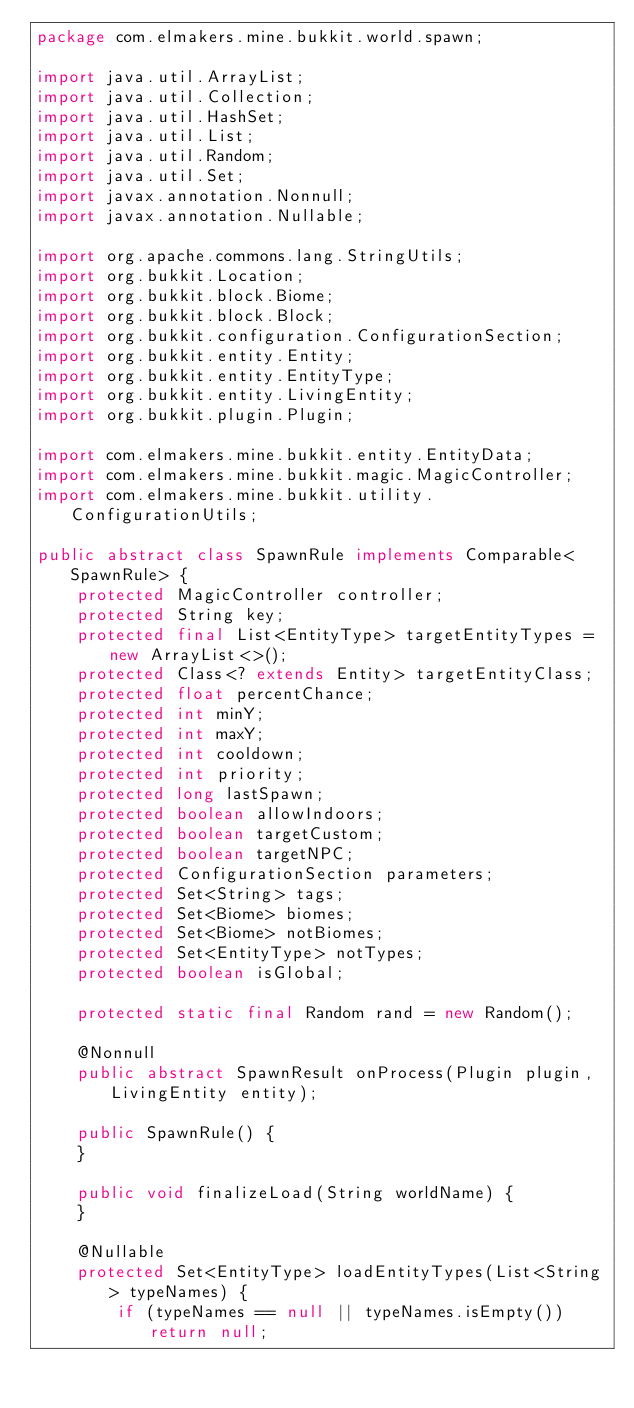<code> <loc_0><loc_0><loc_500><loc_500><_Java_>package com.elmakers.mine.bukkit.world.spawn;

import java.util.ArrayList;
import java.util.Collection;
import java.util.HashSet;
import java.util.List;
import java.util.Random;
import java.util.Set;
import javax.annotation.Nonnull;
import javax.annotation.Nullable;

import org.apache.commons.lang.StringUtils;
import org.bukkit.Location;
import org.bukkit.block.Biome;
import org.bukkit.block.Block;
import org.bukkit.configuration.ConfigurationSection;
import org.bukkit.entity.Entity;
import org.bukkit.entity.EntityType;
import org.bukkit.entity.LivingEntity;
import org.bukkit.plugin.Plugin;

import com.elmakers.mine.bukkit.entity.EntityData;
import com.elmakers.mine.bukkit.magic.MagicController;
import com.elmakers.mine.bukkit.utility.ConfigurationUtils;

public abstract class SpawnRule implements Comparable<SpawnRule> {
    protected MagicController controller;
    protected String key;
    protected final List<EntityType> targetEntityTypes = new ArrayList<>();
    protected Class<? extends Entity> targetEntityClass;
    protected float percentChance;
    protected int minY;
    protected int maxY;
    protected int cooldown;
    protected int priority;
    protected long lastSpawn;
    protected boolean allowIndoors;
    protected boolean targetCustom;
    protected boolean targetNPC;
    protected ConfigurationSection parameters;
    protected Set<String> tags;
    protected Set<Biome> biomes;
    protected Set<Biome> notBiomes;
    protected Set<EntityType> notTypes;
    protected boolean isGlobal;

    protected static final Random rand = new Random();

    @Nonnull
    public abstract SpawnResult onProcess(Plugin plugin, LivingEntity entity);

    public SpawnRule() {
    }

    public void finalizeLoad(String worldName) {
    }

    @Nullable
    protected Set<EntityType> loadEntityTypes(List<String> typeNames) {
        if (typeNames == null || typeNames.isEmpty()) return null;</code> 